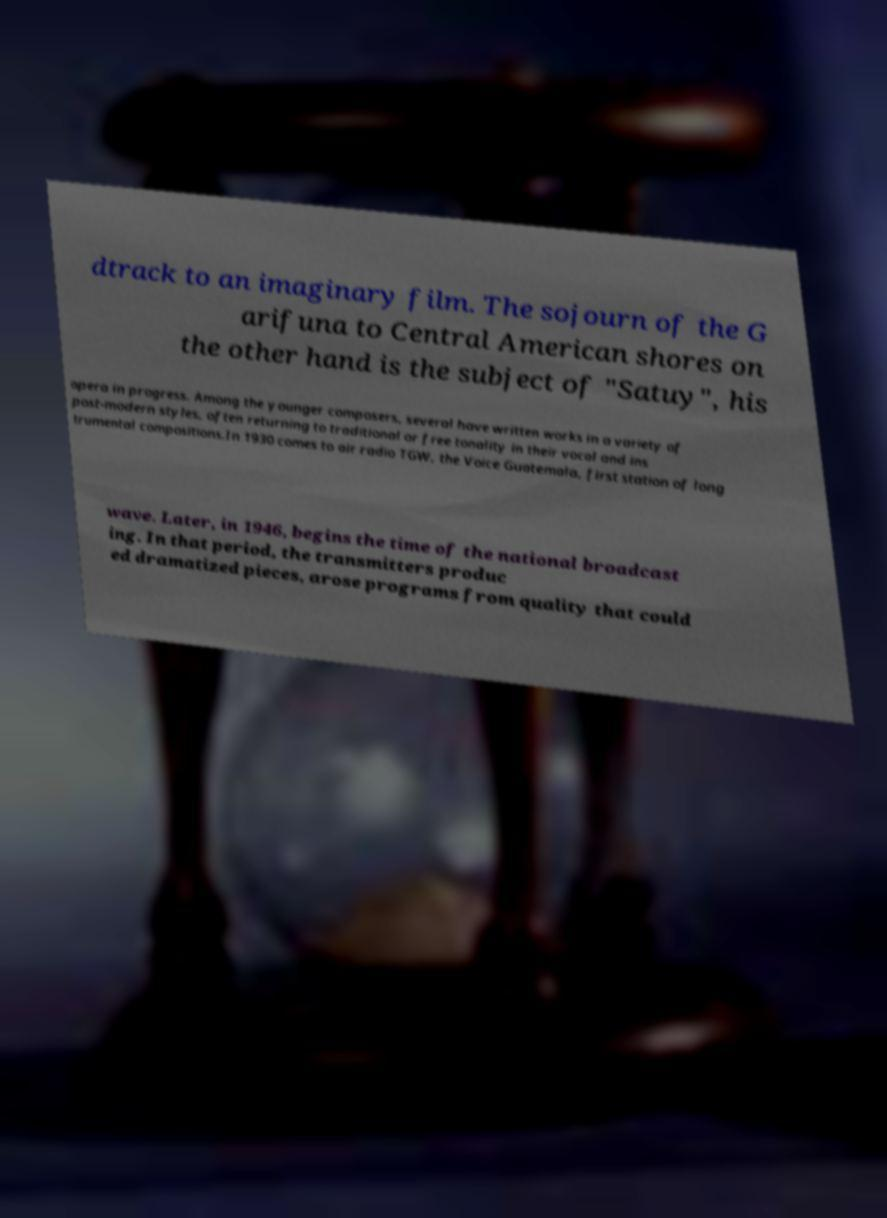Please identify and transcribe the text found in this image. dtrack to an imaginary film. The sojourn of the G arifuna to Central American shores on the other hand is the subject of "Satuy", his opera in progress. Among the younger composers, several have written works in a variety of post-modern styles, often returning to traditional or free tonality in their vocal and ins trumental compositions.In 1930 comes to air radio TGW, the Voice Guatemala, first station of long wave. Later, in 1946, begins the time of the national broadcast ing. In that period, the transmitters produc ed dramatized pieces, arose programs from quality that could 